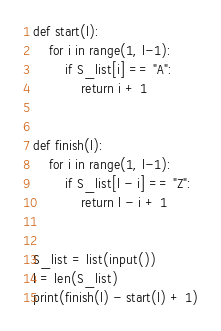<code> <loc_0><loc_0><loc_500><loc_500><_Python_>def start(l):
    for i in range(1, l-1):
        if S_list[i] == "A":
            return i + 1


def finish(l):
    for i in range(1, l-1):
        if S_list[l - i] == "Z":
            return l - i + 1


S_list = list(input())
l = len(S_list)
print(finish(l) - start(l) + 1)</code> 